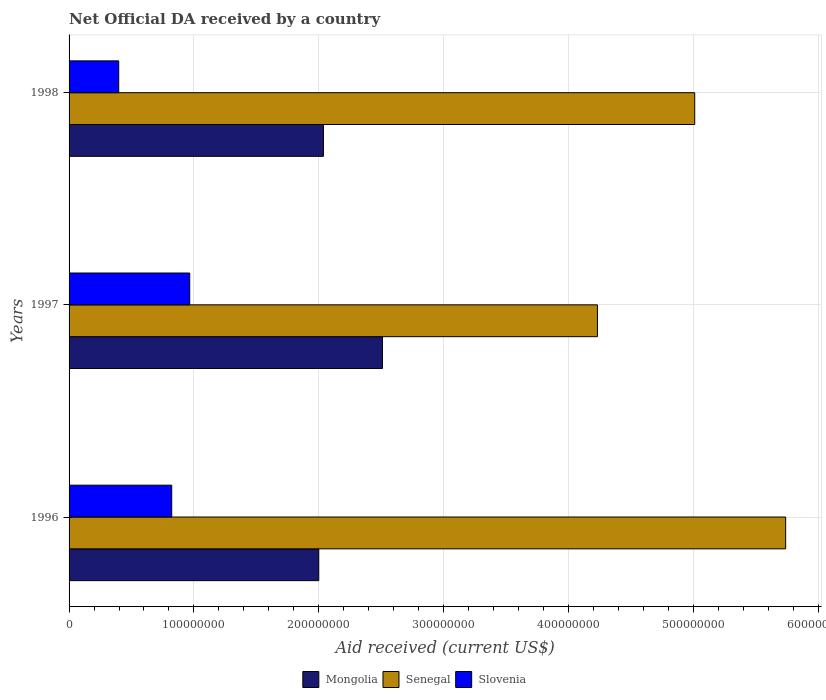How many different coloured bars are there?
Give a very brief answer. 3. How many groups of bars are there?
Ensure brevity in your answer.  3. How many bars are there on the 2nd tick from the bottom?
Keep it short and to the point. 3. What is the label of the 1st group of bars from the top?
Ensure brevity in your answer.  1998. In how many cases, is the number of bars for a given year not equal to the number of legend labels?
Keep it short and to the point. 0. What is the net official development assistance aid received in Slovenia in 1998?
Offer a very short reply. 3.98e+07. Across all years, what is the maximum net official development assistance aid received in Slovenia?
Your answer should be compact. 9.66e+07. Across all years, what is the minimum net official development assistance aid received in Senegal?
Your response must be concise. 4.23e+08. In which year was the net official development assistance aid received in Mongolia maximum?
Your answer should be very brief. 1997. In which year was the net official development assistance aid received in Senegal minimum?
Your answer should be very brief. 1997. What is the total net official development assistance aid received in Senegal in the graph?
Your answer should be compact. 1.50e+09. What is the difference between the net official development assistance aid received in Mongolia in 1996 and that in 1997?
Offer a very short reply. -5.10e+07. What is the difference between the net official development assistance aid received in Slovenia in 1996 and the net official development assistance aid received in Senegal in 1998?
Offer a terse response. -4.19e+08. What is the average net official development assistance aid received in Mongolia per year?
Give a very brief answer. 2.18e+08. In the year 1996, what is the difference between the net official development assistance aid received in Mongolia and net official development assistance aid received in Senegal?
Provide a succinct answer. -3.74e+08. What is the ratio of the net official development assistance aid received in Slovenia in 1996 to that in 1997?
Keep it short and to the point. 0.85. What is the difference between the highest and the second highest net official development assistance aid received in Slovenia?
Make the answer very short. 1.44e+07. What is the difference between the highest and the lowest net official development assistance aid received in Slovenia?
Give a very brief answer. 5.69e+07. What does the 1st bar from the top in 1996 represents?
Offer a very short reply. Slovenia. What does the 3rd bar from the bottom in 1997 represents?
Offer a terse response. Slovenia. Is it the case that in every year, the sum of the net official development assistance aid received in Slovenia and net official development assistance aid received in Senegal is greater than the net official development assistance aid received in Mongolia?
Ensure brevity in your answer.  Yes. Are all the bars in the graph horizontal?
Provide a succinct answer. Yes. How many years are there in the graph?
Offer a very short reply. 3. Are the values on the major ticks of X-axis written in scientific E-notation?
Offer a very short reply. No. How many legend labels are there?
Your answer should be compact. 3. How are the legend labels stacked?
Offer a terse response. Horizontal. What is the title of the graph?
Your answer should be very brief. Net Official DA received by a country. What is the label or title of the X-axis?
Your response must be concise. Aid received (current US$). What is the label or title of the Y-axis?
Your response must be concise. Years. What is the Aid received (current US$) of Mongolia in 1996?
Keep it short and to the point. 2.00e+08. What is the Aid received (current US$) in Senegal in 1996?
Provide a short and direct response. 5.74e+08. What is the Aid received (current US$) of Slovenia in 1996?
Provide a succinct answer. 8.22e+07. What is the Aid received (current US$) in Mongolia in 1997?
Your response must be concise. 2.51e+08. What is the Aid received (current US$) in Senegal in 1997?
Keep it short and to the point. 4.23e+08. What is the Aid received (current US$) in Slovenia in 1997?
Offer a terse response. 9.66e+07. What is the Aid received (current US$) of Mongolia in 1998?
Your answer should be compact. 2.04e+08. What is the Aid received (current US$) of Senegal in 1998?
Your answer should be very brief. 5.01e+08. What is the Aid received (current US$) in Slovenia in 1998?
Provide a short and direct response. 3.98e+07. Across all years, what is the maximum Aid received (current US$) of Mongolia?
Provide a short and direct response. 2.51e+08. Across all years, what is the maximum Aid received (current US$) in Senegal?
Provide a short and direct response. 5.74e+08. Across all years, what is the maximum Aid received (current US$) in Slovenia?
Keep it short and to the point. 9.66e+07. Across all years, what is the minimum Aid received (current US$) in Mongolia?
Your answer should be compact. 2.00e+08. Across all years, what is the minimum Aid received (current US$) in Senegal?
Keep it short and to the point. 4.23e+08. Across all years, what is the minimum Aid received (current US$) in Slovenia?
Offer a very short reply. 3.98e+07. What is the total Aid received (current US$) of Mongolia in the graph?
Provide a short and direct response. 6.55e+08. What is the total Aid received (current US$) of Senegal in the graph?
Ensure brevity in your answer.  1.50e+09. What is the total Aid received (current US$) in Slovenia in the graph?
Your answer should be very brief. 2.19e+08. What is the difference between the Aid received (current US$) of Mongolia in 1996 and that in 1997?
Make the answer very short. -5.10e+07. What is the difference between the Aid received (current US$) in Senegal in 1996 and that in 1997?
Provide a short and direct response. 1.51e+08. What is the difference between the Aid received (current US$) of Slovenia in 1996 and that in 1997?
Provide a short and direct response. -1.44e+07. What is the difference between the Aid received (current US$) in Mongolia in 1996 and that in 1998?
Your answer should be very brief. -3.74e+06. What is the difference between the Aid received (current US$) in Senegal in 1996 and that in 1998?
Ensure brevity in your answer.  7.28e+07. What is the difference between the Aid received (current US$) in Slovenia in 1996 and that in 1998?
Provide a succinct answer. 4.24e+07. What is the difference between the Aid received (current US$) in Mongolia in 1997 and that in 1998?
Ensure brevity in your answer.  4.72e+07. What is the difference between the Aid received (current US$) in Senegal in 1997 and that in 1998?
Offer a terse response. -7.79e+07. What is the difference between the Aid received (current US$) in Slovenia in 1997 and that in 1998?
Your answer should be very brief. 5.69e+07. What is the difference between the Aid received (current US$) in Mongolia in 1996 and the Aid received (current US$) in Senegal in 1997?
Provide a succinct answer. -2.23e+08. What is the difference between the Aid received (current US$) in Mongolia in 1996 and the Aid received (current US$) in Slovenia in 1997?
Provide a short and direct response. 1.03e+08. What is the difference between the Aid received (current US$) in Senegal in 1996 and the Aid received (current US$) in Slovenia in 1997?
Your response must be concise. 4.77e+08. What is the difference between the Aid received (current US$) in Mongolia in 1996 and the Aid received (current US$) in Senegal in 1998?
Give a very brief answer. -3.01e+08. What is the difference between the Aid received (current US$) in Mongolia in 1996 and the Aid received (current US$) in Slovenia in 1998?
Provide a succinct answer. 1.60e+08. What is the difference between the Aid received (current US$) in Senegal in 1996 and the Aid received (current US$) in Slovenia in 1998?
Your response must be concise. 5.34e+08. What is the difference between the Aid received (current US$) in Mongolia in 1997 and the Aid received (current US$) in Senegal in 1998?
Offer a terse response. -2.50e+08. What is the difference between the Aid received (current US$) of Mongolia in 1997 and the Aid received (current US$) of Slovenia in 1998?
Give a very brief answer. 2.11e+08. What is the difference between the Aid received (current US$) of Senegal in 1997 and the Aid received (current US$) of Slovenia in 1998?
Offer a terse response. 3.83e+08. What is the average Aid received (current US$) in Mongolia per year?
Provide a succinct answer. 2.18e+08. What is the average Aid received (current US$) in Senegal per year?
Give a very brief answer. 4.99e+08. What is the average Aid received (current US$) in Slovenia per year?
Keep it short and to the point. 7.29e+07. In the year 1996, what is the difference between the Aid received (current US$) of Mongolia and Aid received (current US$) of Senegal?
Offer a very short reply. -3.74e+08. In the year 1996, what is the difference between the Aid received (current US$) of Mongolia and Aid received (current US$) of Slovenia?
Provide a short and direct response. 1.18e+08. In the year 1996, what is the difference between the Aid received (current US$) of Senegal and Aid received (current US$) of Slovenia?
Keep it short and to the point. 4.92e+08. In the year 1997, what is the difference between the Aid received (current US$) in Mongolia and Aid received (current US$) in Senegal?
Keep it short and to the point. -1.72e+08. In the year 1997, what is the difference between the Aid received (current US$) of Mongolia and Aid received (current US$) of Slovenia?
Give a very brief answer. 1.54e+08. In the year 1997, what is the difference between the Aid received (current US$) in Senegal and Aid received (current US$) in Slovenia?
Keep it short and to the point. 3.27e+08. In the year 1998, what is the difference between the Aid received (current US$) in Mongolia and Aid received (current US$) in Senegal?
Provide a succinct answer. -2.97e+08. In the year 1998, what is the difference between the Aid received (current US$) of Mongolia and Aid received (current US$) of Slovenia?
Offer a very short reply. 1.64e+08. In the year 1998, what is the difference between the Aid received (current US$) in Senegal and Aid received (current US$) in Slovenia?
Keep it short and to the point. 4.61e+08. What is the ratio of the Aid received (current US$) of Mongolia in 1996 to that in 1997?
Your response must be concise. 0.8. What is the ratio of the Aid received (current US$) in Senegal in 1996 to that in 1997?
Offer a very short reply. 1.36. What is the ratio of the Aid received (current US$) in Slovenia in 1996 to that in 1997?
Give a very brief answer. 0.85. What is the ratio of the Aid received (current US$) in Mongolia in 1996 to that in 1998?
Keep it short and to the point. 0.98. What is the ratio of the Aid received (current US$) in Senegal in 1996 to that in 1998?
Provide a succinct answer. 1.15. What is the ratio of the Aid received (current US$) in Slovenia in 1996 to that in 1998?
Your answer should be compact. 2.07. What is the ratio of the Aid received (current US$) of Mongolia in 1997 to that in 1998?
Ensure brevity in your answer.  1.23. What is the ratio of the Aid received (current US$) of Senegal in 1997 to that in 1998?
Make the answer very short. 0.84. What is the ratio of the Aid received (current US$) of Slovenia in 1997 to that in 1998?
Your answer should be very brief. 2.43. What is the difference between the highest and the second highest Aid received (current US$) in Mongolia?
Your answer should be compact. 4.72e+07. What is the difference between the highest and the second highest Aid received (current US$) of Senegal?
Your response must be concise. 7.28e+07. What is the difference between the highest and the second highest Aid received (current US$) of Slovenia?
Your answer should be very brief. 1.44e+07. What is the difference between the highest and the lowest Aid received (current US$) of Mongolia?
Provide a short and direct response. 5.10e+07. What is the difference between the highest and the lowest Aid received (current US$) in Senegal?
Your answer should be very brief. 1.51e+08. What is the difference between the highest and the lowest Aid received (current US$) of Slovenia?
Your response must be concise. 5.69e+07. 